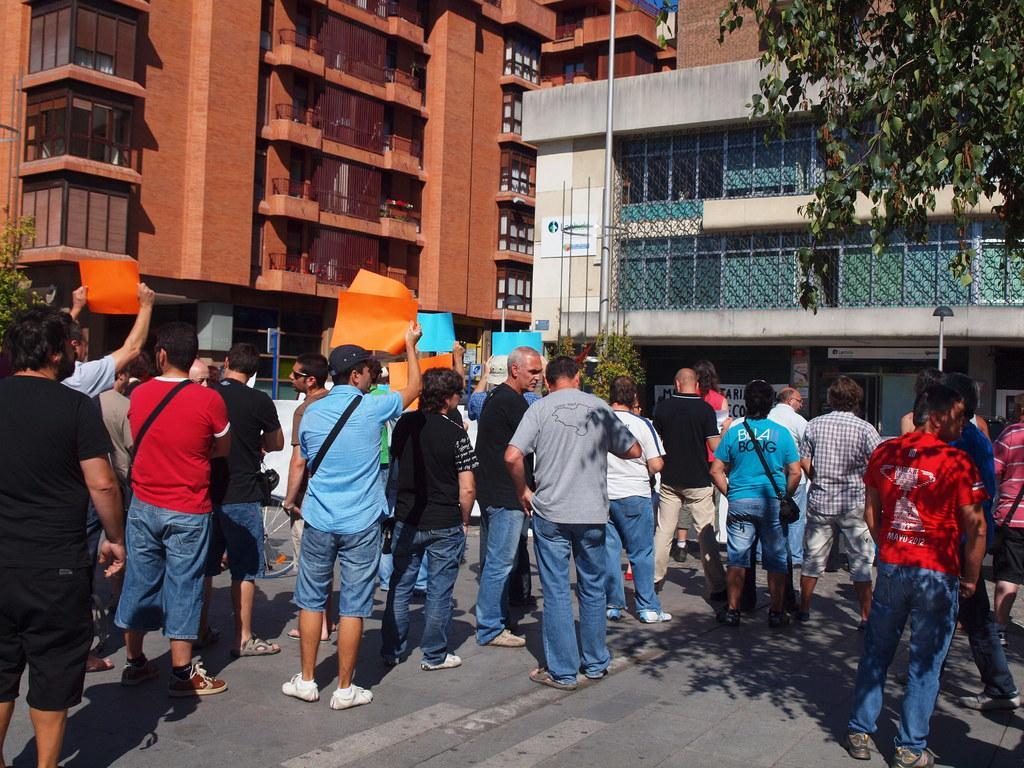How would you summarize this image in a sentence or two? In this image we can see these people are standing on the road and these people are holding placards. Here we can see poles, trees and buildings in the background. 